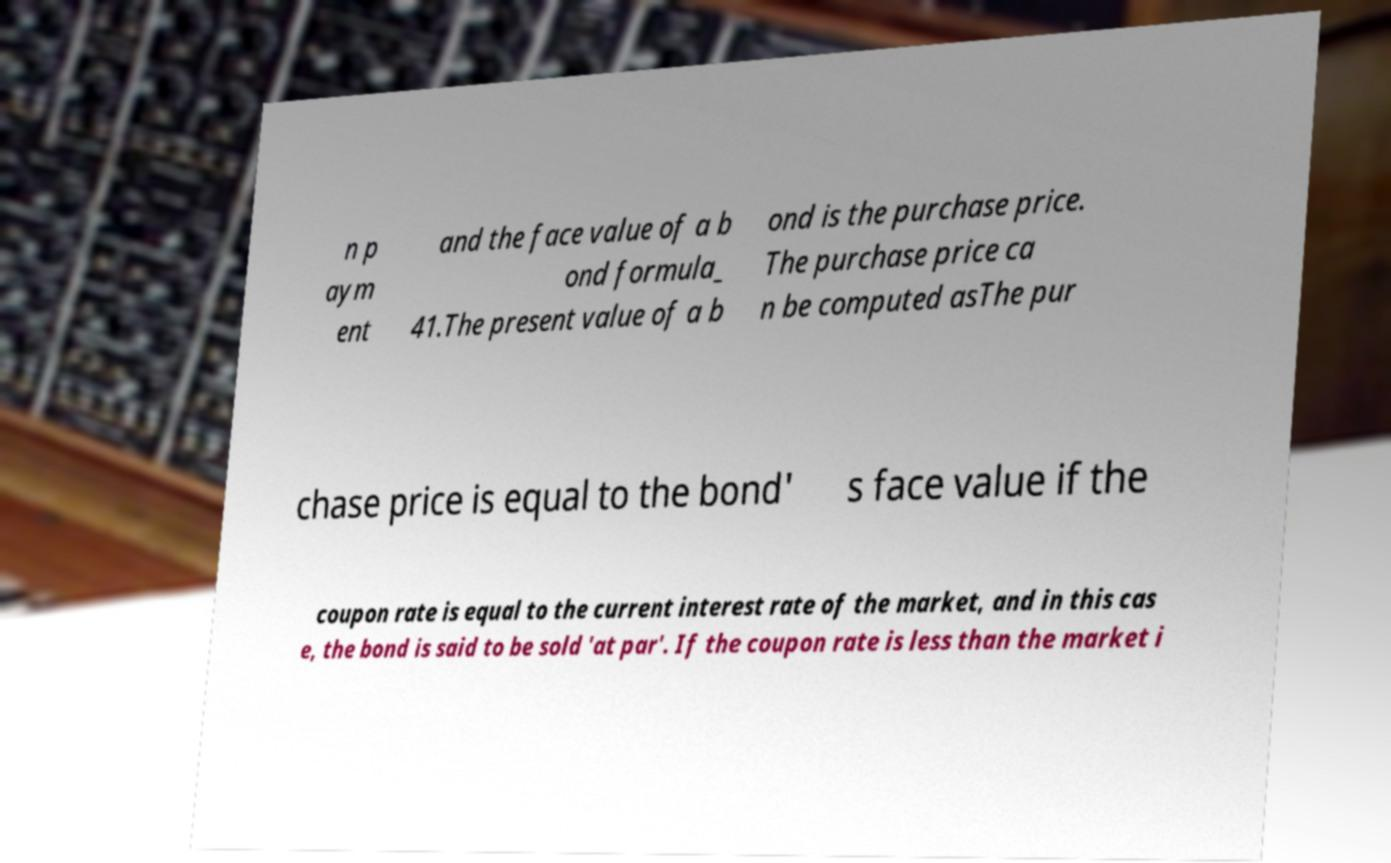For documentation purposes, I need the text within this image transcribed. Could you provide that? n p aym ent and the face value of a b ond formula_ 41.The present value of a b ond is the purchase price. The purchase price ca n be computed asThe pur chase price is equal to the bond' s face value if the coupon rate is equal to the current interest rate of the market, and in this cas e, the bond is said to be sold 'at par'. If the coupon rate is less than the market i 